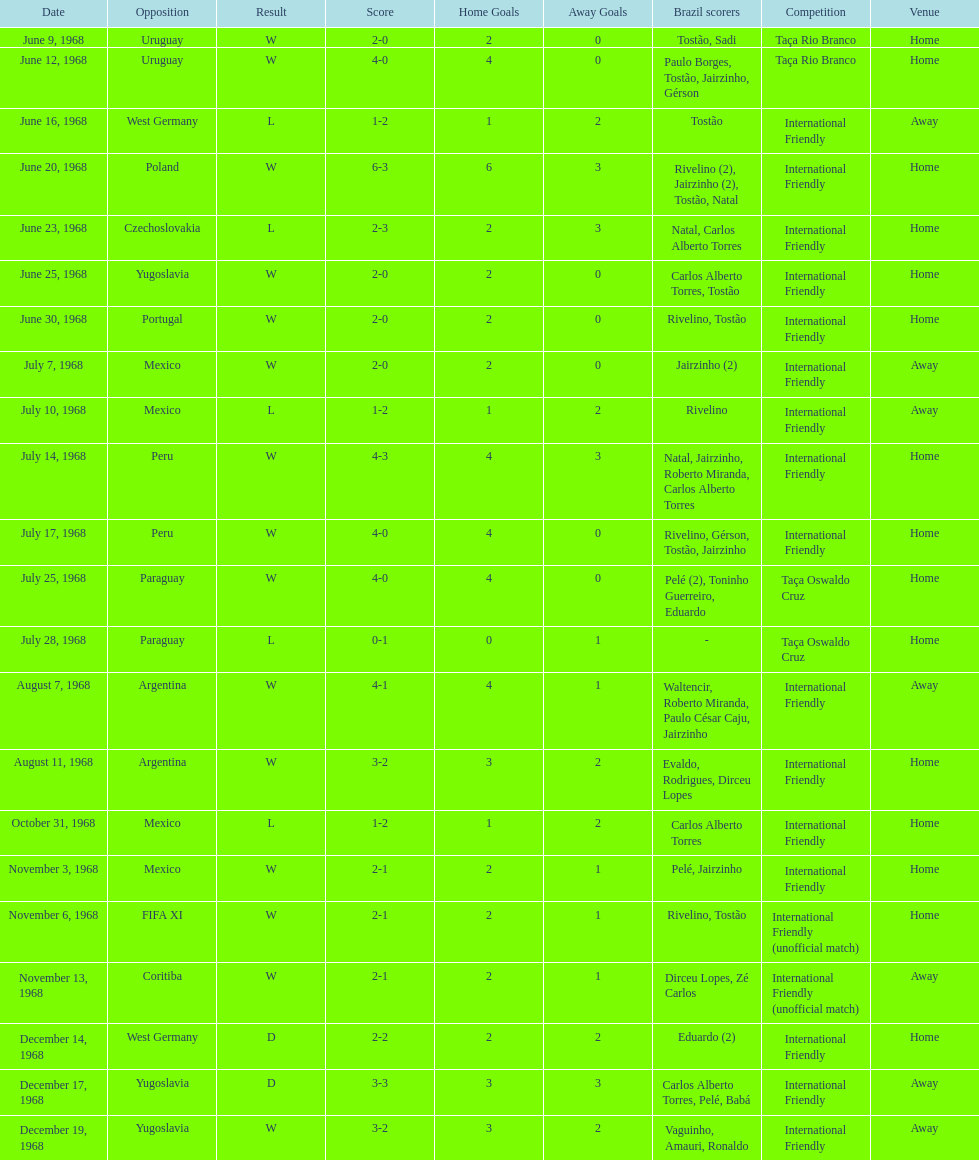Help me parse the entirety of this table. {'header': ['Date', 'Opposition', 'Result', 'Score', 'Home Goals', 'Away Goals', 'Brazil scorers', 'Competition', 'Venue'], 'rows': [['June 9, 1968', 'Uruguay', 'W', '2-0', '2', '0', 'Tostão, Sadi', 'Taça Rio Branco', 'Home'], ['June 12, 1968', 'Uruguay', 'W', '4-0', '4', '0', 'Paulo Borges, Tostão, Jairzinho, Gérson', 'Taça Rio Branco', 'Home'], ['June 16, 1968', 'West Germany', 'L', '1-2', '1', '2', 'Tostão', 'International Friendly', 'Away'], ['June 20, 1968', 'Poland', 'W', '6-3', '6', '3', 'Rivelino (2), Jairzinho (2), Tostão, Natal', 'International Friendly', 'Home'], ['June 23, 1968', 'Czechoslovakia', 'L', '2-3', '2', '3', 'Natal, Carlos Alberto Torres', 'International Friendly', 'Home'], ['June 25, 1968', 'Yugoslavia', 'W', '2-0', '2', '0', 'Carlos Alberto Torres, Tostão', 'International Friendly', 'Home'], ['June 30, 1968', 'Portugal', 'W', '2-0', '2', '0', 'Rivelino, Tostão', 'International Friendly', 'Home'], ['July 7, 1968', 'Mexico', 'W', '2-0', '2', '0', 'Jairzinho (2)', 'International Friendly', 'Away'], ['July 10, 1968', 'Mexico', 'L', '1-2', '1', '2', 'Rivelino', 'International Friendly', 'Away'], ['July 14, 1968', 'Peru', 'W', '4-3', '4', '3', 'Natal, Jairzinho, Roberto Miranda, Carlos Alberto Torres', 'International Friendly', 'Home'], ['July 17, 1968', 'Peru', 'W', '4-0', '4', '0', 'Rivelino, Gérson, Tostão, Jairzinho', 'International Friendly', 'Home'], ['July 25, 1968', 'Paraguay', 'W', '4-0', '4', '0', 'Pelé (2), Toninho Guerreiro, Eduardo', 'Taça Oswaldo Cruz', 'Home'], ['July 28, 1968', 'Paraguay', 'L', '0-1', '0', '1', '-', 'Taça Oswaldo Cruz', 'Home'], ['August 7, 1968', 'Argentina', 'W', '4-1', '4', '1', 'Waltencir, Roberto Miranda, Paulo César Caju, Jairzinho', 'International Friendly', 'Away'], ['August 11, 1968', 'Argentina', 'W', '3-2', '3', '2', 'Evaldo, Rodrigues, Dirceu Lopes', 'International Friendly', 'Home'], ['October 31, 1968', 'Mexico', 'L', '1-2', '1', '2', 'Carlos Alberto Torres', 'International Friendly', 'Home'], ['November 3, 1968', 'Mexico', 'W', '2-1', '2', '1', 'Pelé, Jairzinho', 'International Friendly', 'Home'], ['November 6, 1968', 'FIFA XI', 'W', '2-1', '2', '1', 'Rivelino, Tostão', 'International Friendly (unofficial match)', 'Home'], ['November 13, 1968', 'Coritiba', 'W', '2-1', '2', '1', 'Dirceu Lopes, Zé Carlos', 'International Friendly (unofficial match)', 'Away'], ['December 14, 1968', 'West Germany', 'D', '2-2', '2', '2', 'Eduardo (2)', 'International Friendly', 'Home'], ['December 17, 1968', 'Yugoslavia', 'D', '3-3', '3', '3', 'Carlos Alberto Torres, Pelé, Babá', 'International Friendly', 'Away'], ['December 19, 1968', 'Yugoslavia', 'W', '3-2', '3', '2', 'Vaguinho, Amauri, Ronaldo', 'International Friendly', 'Away']]} Name the first competition ever played by brazil. Taça Rio Branco. 